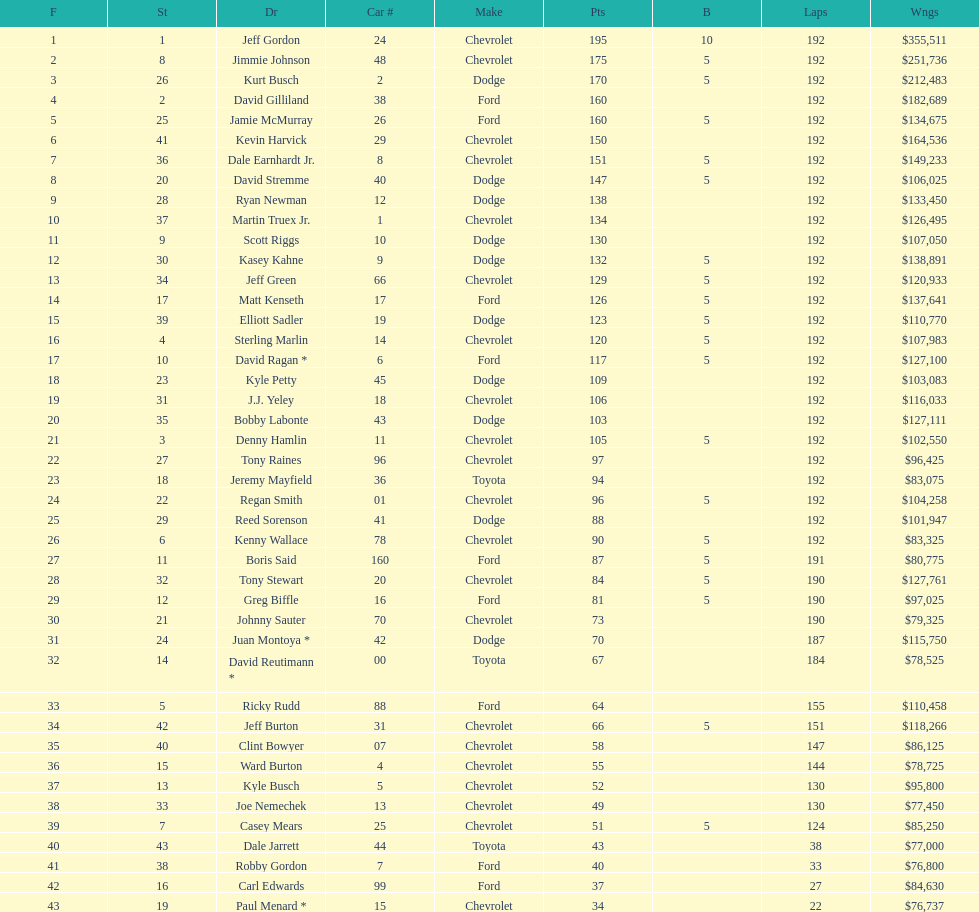What driver earned the least amount of winnings? Paul Menard *. 